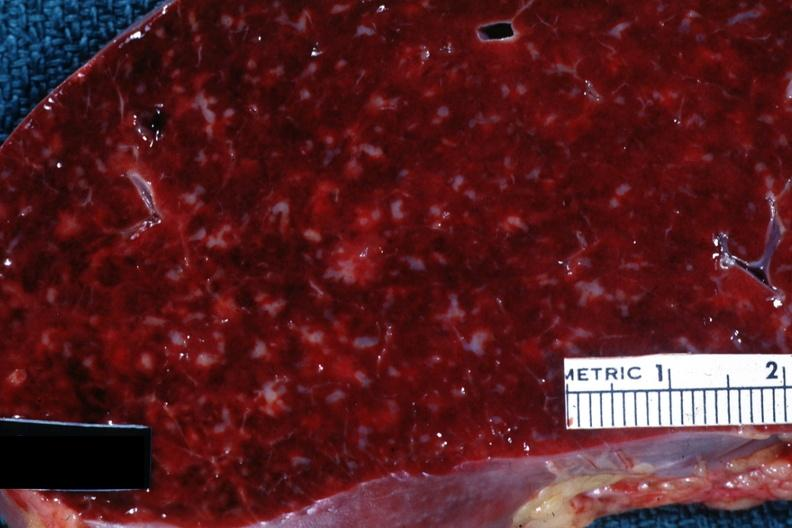where is this part in?
Answer the question using a single word or phrase. Spleen 